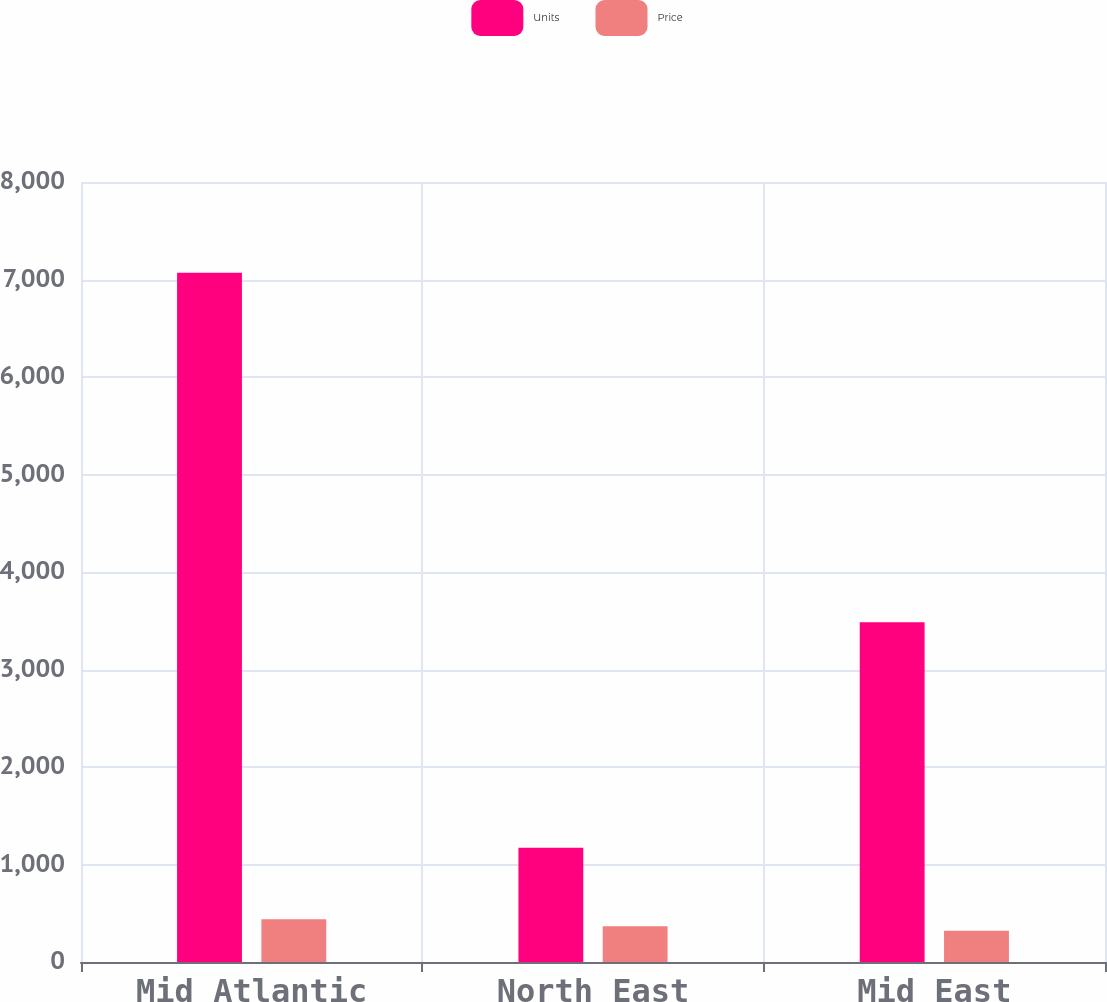Convert chart. <chart><loc_0><loc_0><loc_500><loc_500><stacked_bar_chart><ecel><fcel>Mid Atlantic<fcel>North East<fcel>Mid East<nl><fcel>Units<fcel>7070<fcel>1173<fcel>3485<nl><fcel>Price<fcel>439.5<fcel>365.9<fcel>321.4<nl></chart> 